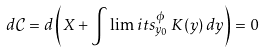Convert formula to latex. <formula><loc_0><loc_0><loc_500><loc_500>d \mathcal { C } = d \left ( X + \int \lim i t s _ { y _ { 0 } } ^ { \phi } \, K ( y ) \, d y \right ) = 0</formula> 